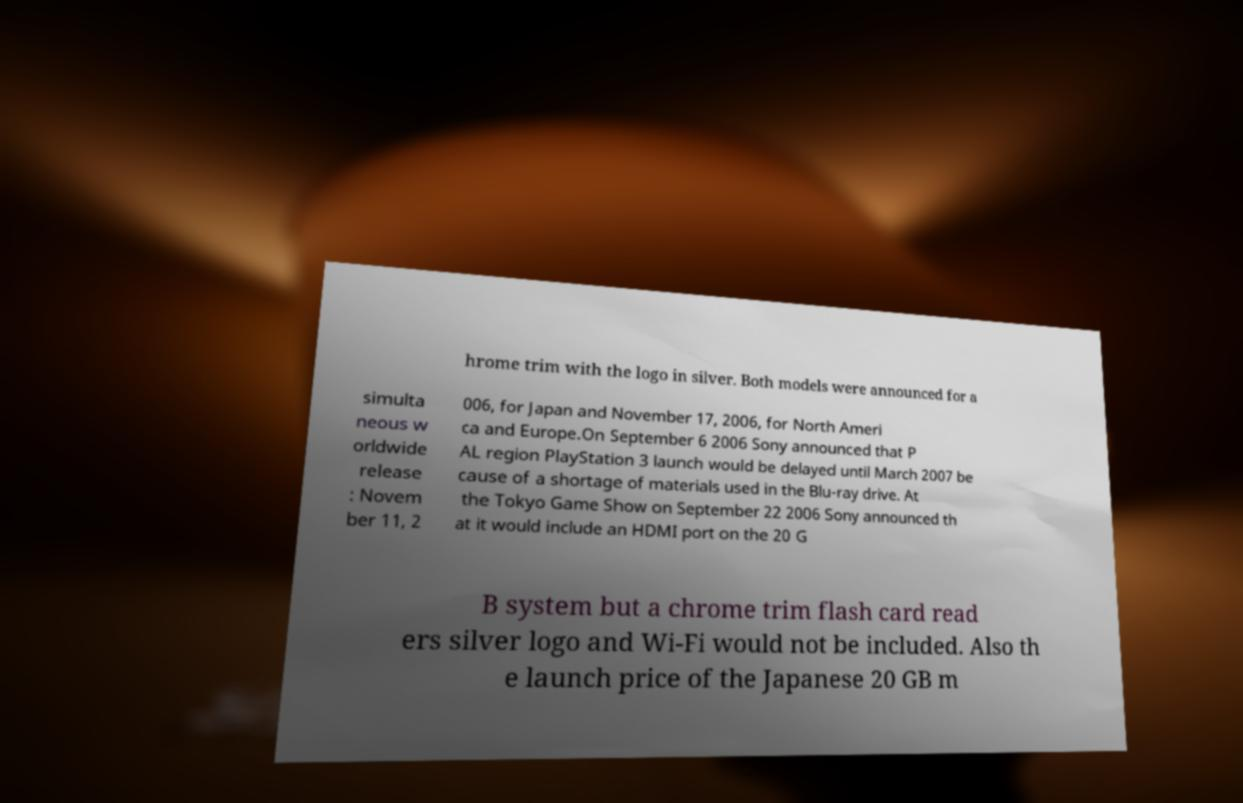Can you read and provide the text displayed in the image?This photo seems to have some interesting text. Can you extract and type it out for me? hrome trim with the logo in silver. Both models were announced for a simulta neous w orldwide release : Novem ber 11, 2 006, for Japan and November 17, 2006, for North Ameri ca and Europe.On September 6 2006 Sony announced that P AL region PlayStation 3 launch would be delayed until March 2007 be cause of a shortage of materials used in the Blu-ray drive. At the Tokyo Game Show on September 22 2006 Sony announced th at it would include an HDMI port on the 20 G B system but a chrome trim flash card read ers silver logo and Wi-Fi would not be included. Also th e launch price of the Japanese 20 GB m 